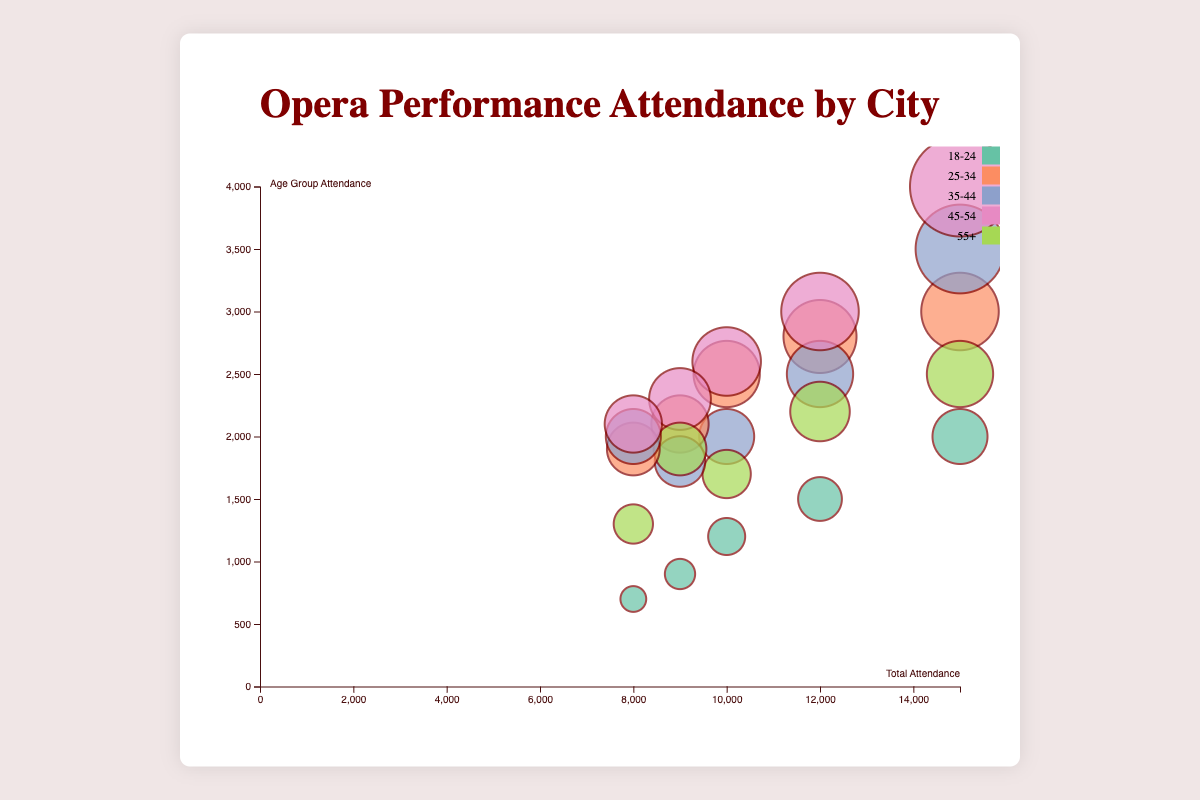How many cities are represented in the chart? We look at the title and the data in the figure. Counting the unique city names gives us the total number.
Answer: 5 Which city has the highest overall attendance? Identify the bubble with the highest x-axis value, which represents total attendance.
Answer: New York What is the total attendance for Los Angeles? Find the bubble for Los Angeles and look at the x-axis value corresponding to it.
Answer: 12,000 Which age group showed the highest attendance in Chicago? For the city of Chicago, identify the largest y-axis value among its age groups.
Answer: 45-54 Among the 18-24 age group, which city had the largest attendance? Compare the bubble sizes and y-axis positions for the 18-24 age group across all cities.
Answer: New York What is the combined attendance for age group 25-34 across all cities? Sum the attendance values for the 25-34 age group in each city.
Answer: 12,300 Compare the attendance of the 55+ age group between San Francisco and Houston. Which city has more? Look at the y-axis values for the 55+ age group for both cities and compare them.
Answer: San Francisco How does Houston's attendance for the 35-44 age group compare to Los Angeles? Compare the y-axis values for the 35-44 age group for both Houston and Los Angeles.
Answer: Los Angeles has more What is the average total attendance of all cities? Sum the total attendance values for all cities and divide by the number of cities.
Answer: 10,400 Identify the city with the smallest bubble for the 18-24 age group. Look at the size of the bubbles representing the 18-24 age group in each city and find the smallest one.
Answer: Houston 